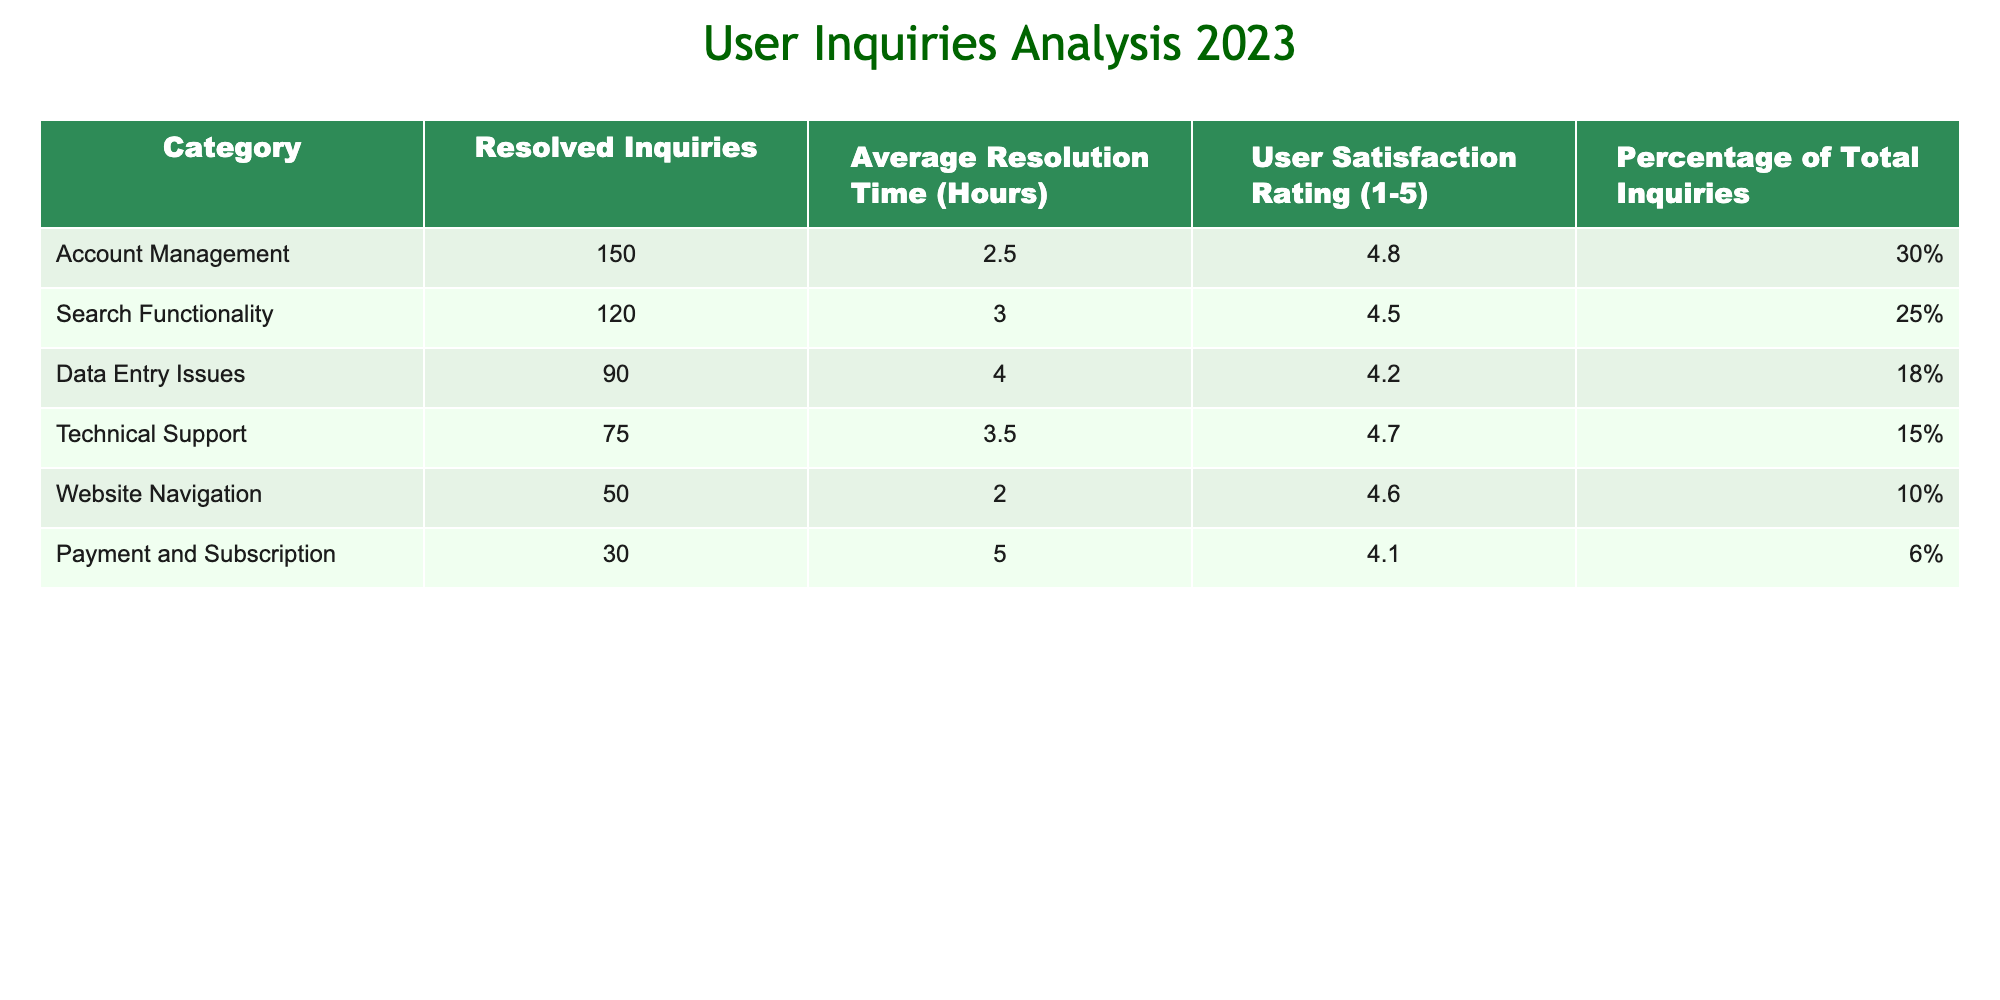What is the category with the highest number of resolved inquiries? The resolved inquiries are listed by category. By looking at the "Resolved Inquiries" column, we see that "Account Management" has 150 resolved inquiries, which is the highest among all categories.
Answer: Account Management What is the average resolution time for Data Entry Issues? The "Average Resolution Time (Hours)" for the category "Data Entry Issues" is directly provided in the table. It shows a value of 4.0 hours.
Answer: 4.0 Is the user satisfaction rating for Payment and Subscription higher than 4.5? The "User Satisfaction Rating" for "Payment and Subscription" is 4.1, which is lower than 4.5. This can be determined by comparing this specific value with 4.5.
Answer: No What is the total percentage of inquiries for Technical Support and Website Navigation? To find the total percentage, we need to look at the specific percentages for both categories and sum them up: 15% (Technical Support) + 10% (Website Navigation) = 25%.
Answer: 25% Which category has the lowest average resolution time? By examining the "Average Resolution Time (Hours)" column, we see that "Website Navigation" has the lowest time at 2.0 hours, which indicates it is resolved the quickest.
Answer: Website Navigation What is the difference in resolved inquiries between Search Functionality and Technical Support? The resolved inquiries for "Search Functionality" are 120 and for "Technical Support," they are 75. The difference is calculated as 120 - 75 = 45.
Answer: 45 Are there more resolved inquiries in the Account Management category compared to the sum of resolved inquiries in Payment and Subscription? The resolved inquiries for "Account Management" is 150, while the sum of "Payment and Subscription" inquiries is 30. Since 150 is greater than 30, this condition holds true.
Answer: Yes What is the average user satisfaction rating among all categories? To calculate the average user satisfaction rating, we sum the ratings: (4.8 + 4.5 + 4.2 + 4.7 + 4.6 + 4.1) = 26.9. There are 6 categories, so the average would be 26.9 / 6 = approximately 4.48.
Answer: 4.48 What category has the highest user satisfaction rating? By checking the "User Satisfaction Rating" column, "Account Management" has the highest rating of 4.8 compared to the other categories.
Answer: Account Management 